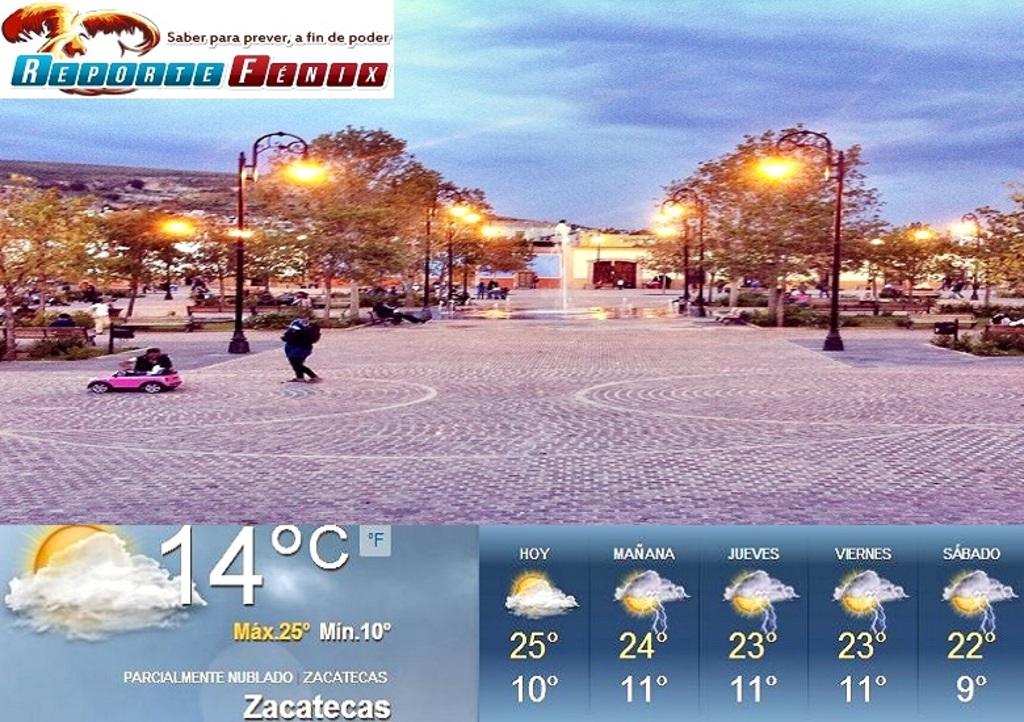What is the current temperature?
Give a very brief answer. 14. What does it say in the red boxes on the top?
Ensure brevity in your answer.  Fenix. 